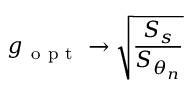Convert formula to latex. <formula><loc_0><loc_0><loc_500><loc_500>g _ { o p t } \rightarrow \sqrt { \frac { S _ { s } } { S _ { \theta _ { n } } } }</formula> 